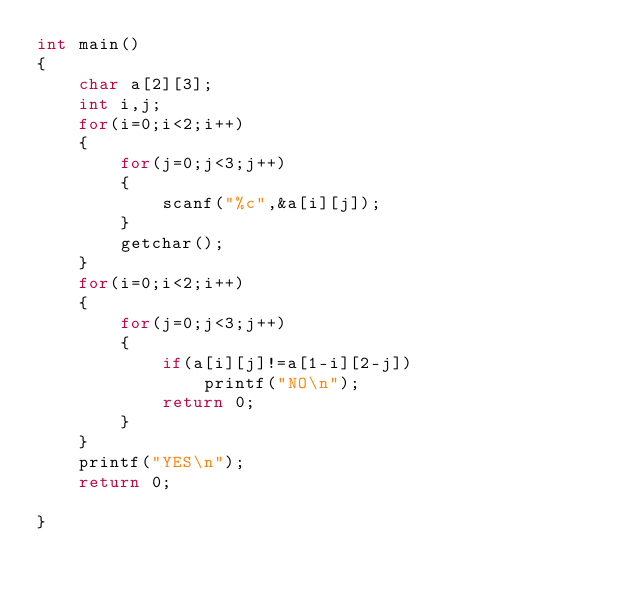Convert code to text. <code><loc_0><loc_0><loc_500><loc_500><_C_>int main()
{
    char a[2][3];
    int i,j;
    for(i=0;i<2;i++)
    {
        for(j=0;j<3;j++)
        {
            scanf("%c",&a[i][j]);
        }
        getchar();
    }
    for(i=0;i<2;i++)
    {
        for(j=0;j<3;j++)
        {
            if(a[i][j]!=a[1-i][2-j])
                printf("NO\n");
            return 0;
        }
    }
    printf("YES\n");
    return 0;

}
</code> 